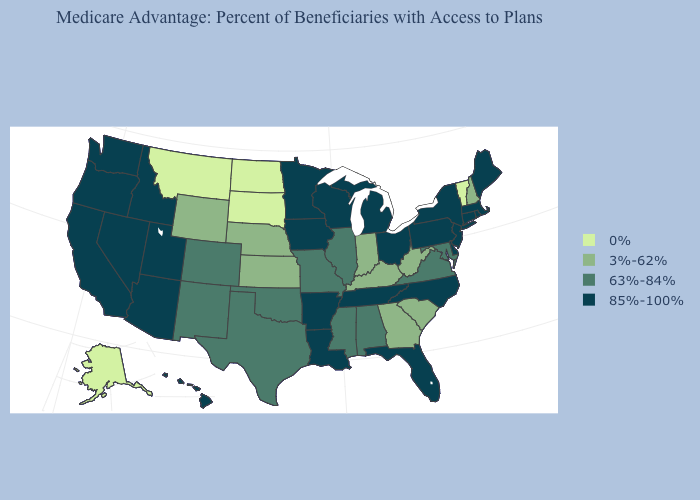Which states have the lowest value in the USA?
Keep it brief. Alaska, Montana, North Dakota, South Dakota, Vermont. What is the value of West Virginia?
Be succinct. 3%-62%. Which states hav the highest value in the South?
Be succinct. Arkansas, Delaware, Florida, Louisiana, North Carolina, Tennessee. What is the highest value in the MidWest ?
Quick response, please. 85%-100%. How many symbols are there in the legend?
Write a very short answer. 4. Among the states that border New York , does Pennsylvania have the lowest value?
Give a very brief answer. No. Among the states that border Illinois , does Iowa have the highest value?
Be succinct. Yes. What is the highest value in the USA?
Be succinct. 85%-100%. Among the states that border North Carolina , which have the lowest value?
Give a very brief answer. Georgia, South Carolina. What is the value of Kansas?
Concise answer only. 3%-62%. What is the value of Maryland?
Keep it brief. 63%-84%. What is the highest value in the USA?
Give a very brief answer. 85%-100%. How many symbols are there in the legend?
Keep it brief. 4. Does Connecticut have the same value as Alabama?
Write a very short answer. No. Name the states that have a value in the range 63%-84%?
Quick response, please. Alabama, Colorado, Illinois, Maryland, Missouri, Mississippi, New Mexico, Oklahoma, Texas, Virginia. 